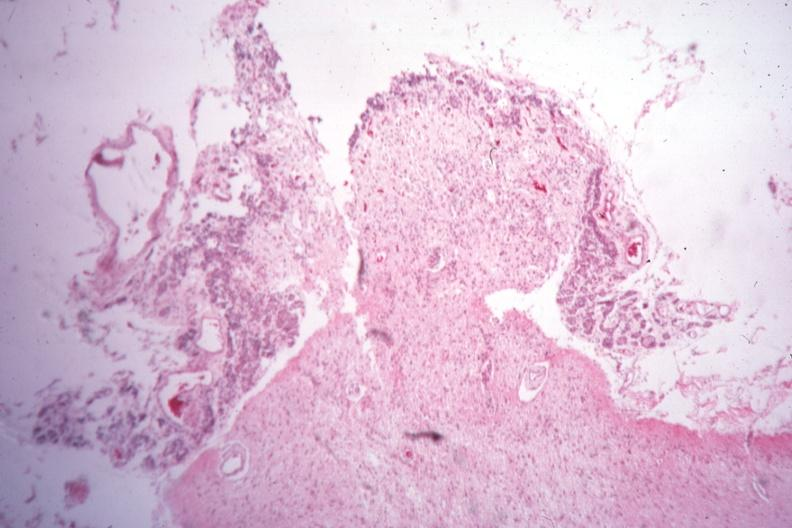what was empty case of type i diabetes with pituitectomy for retinal lesions 9 years?
Answer the question using a single word or phrase. Section through pituitary stalk showing what remains sella 